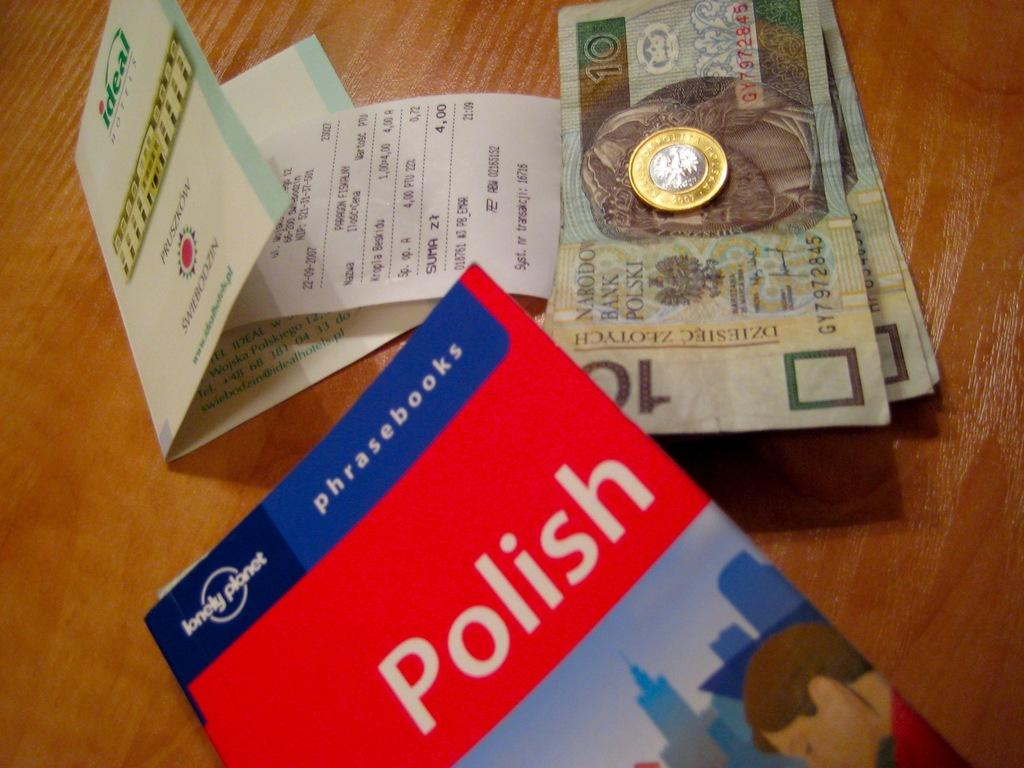<image>
Share a concise interpretation of the image provided. A book of Polish phrasebooks is on a table. 